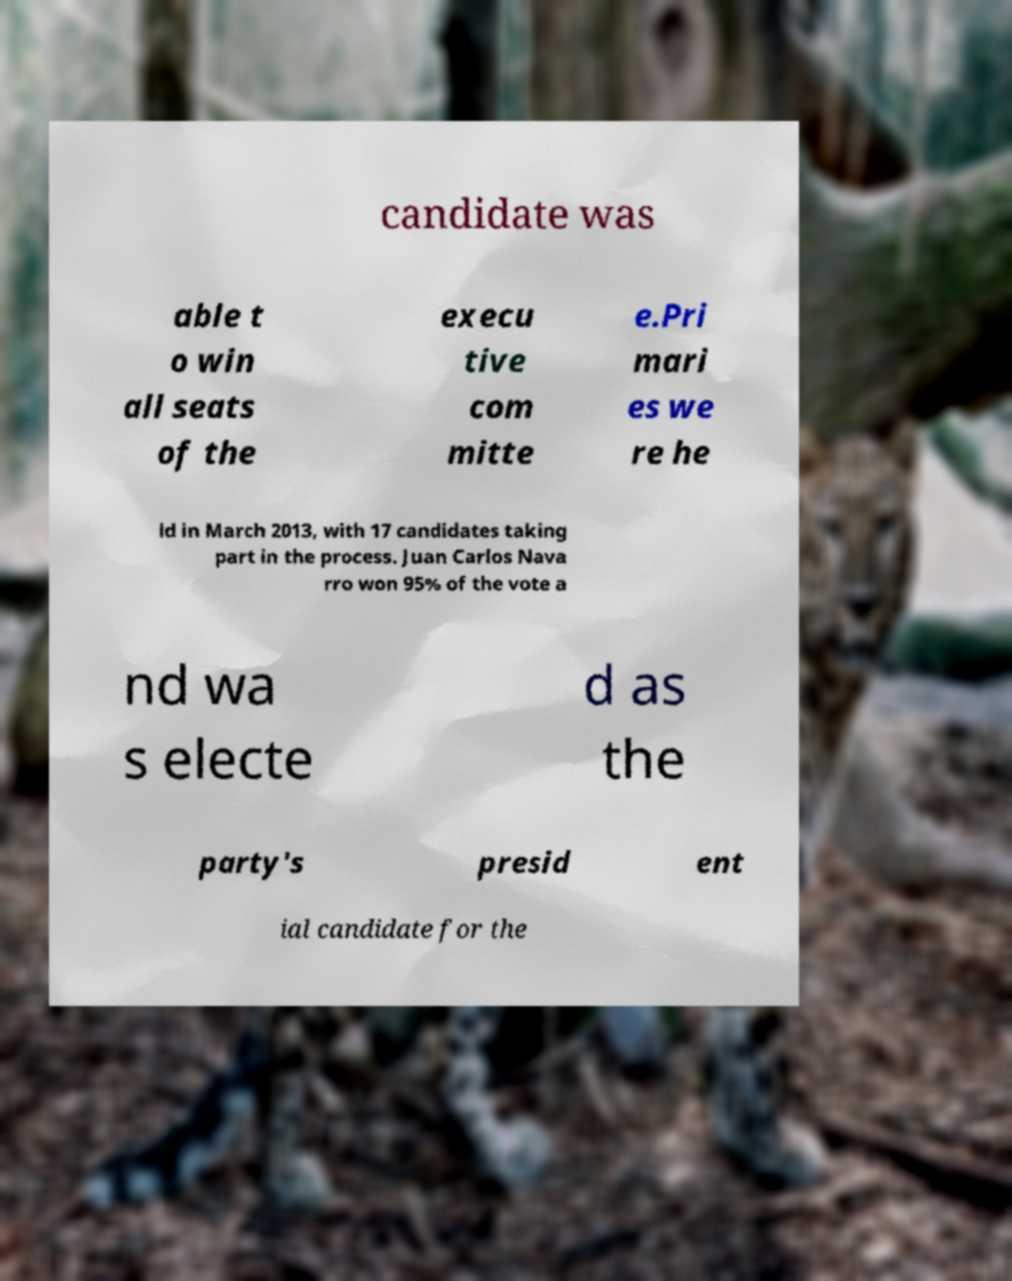There's text embedded in this image that I need extracted. Can you transcribe it verbatim? candidate was able t o win all seats of the execu tive com mitte e.Pri mari es we re he ld in March 2013, with 17 candidates taking part in the process. Juan Carlos Nava rro won 95% of the vote a nd wa s electe d as the party's presid ent ial candidate for the 